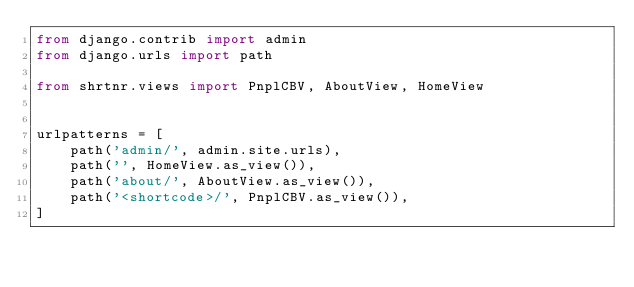<code> <loc_0><loc_0><loc_500><loc_500><_Python_>from django.contrib import admin
from django.urls import path

from shrtnr.views import PnplCBV, AboutView, HomeView


urlpatterns = [
    path('admin/', admin.site.urls),
    path('', HomeView.as_view()),
    path('about/', AboutView.as_view()),
    path('<shortcode>/', PnplCBV.as_view()),
]
</code> 